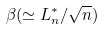<formula> <loc_0><loc_0><loc_500><loc_500>\beta ( \simeq L _ { n } ^ { * } / \sqrt { n } )</formula> 